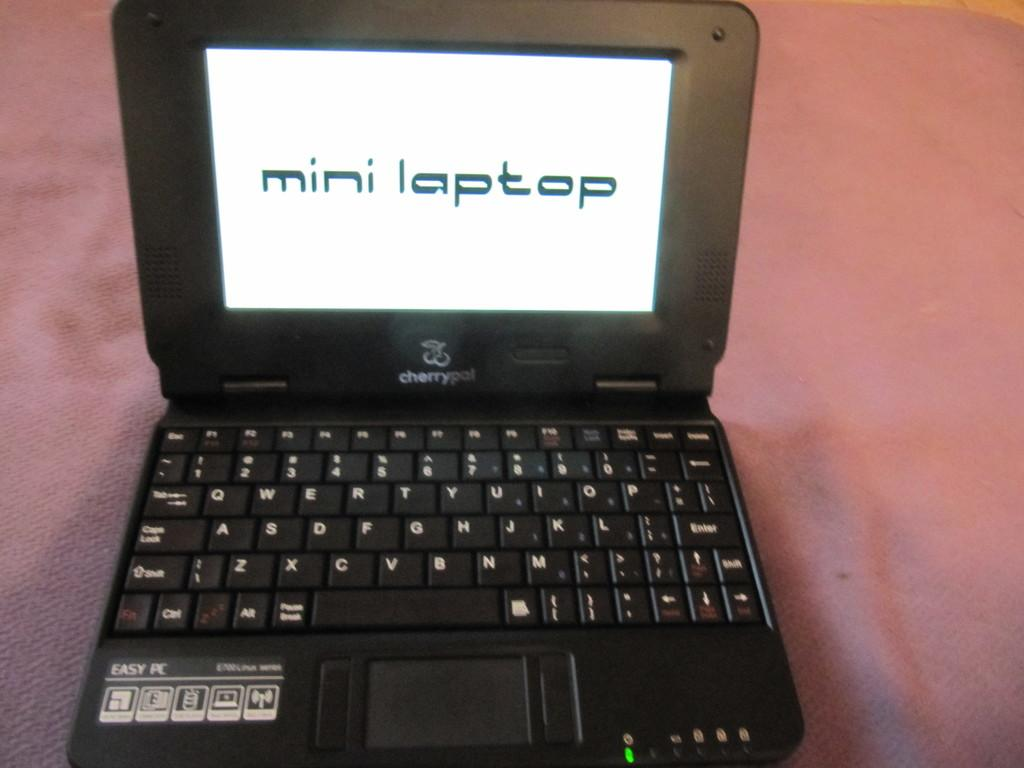<image>
Describe the image concisely. A black laptop made by Cherrypal and displaying that it is a mini laptop. 